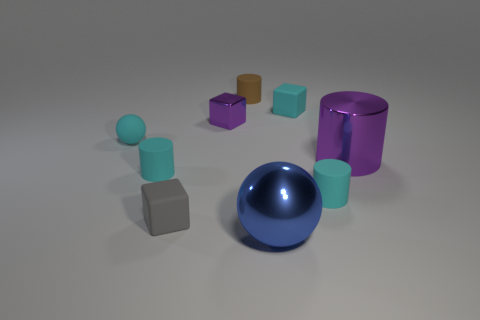Can you describe the lighting of the scene? The scene is lit with a soft, diffused light coming from the upper left, which creates subtle shadows beneath the objects on the right side of the image, indicating a single source of light. 